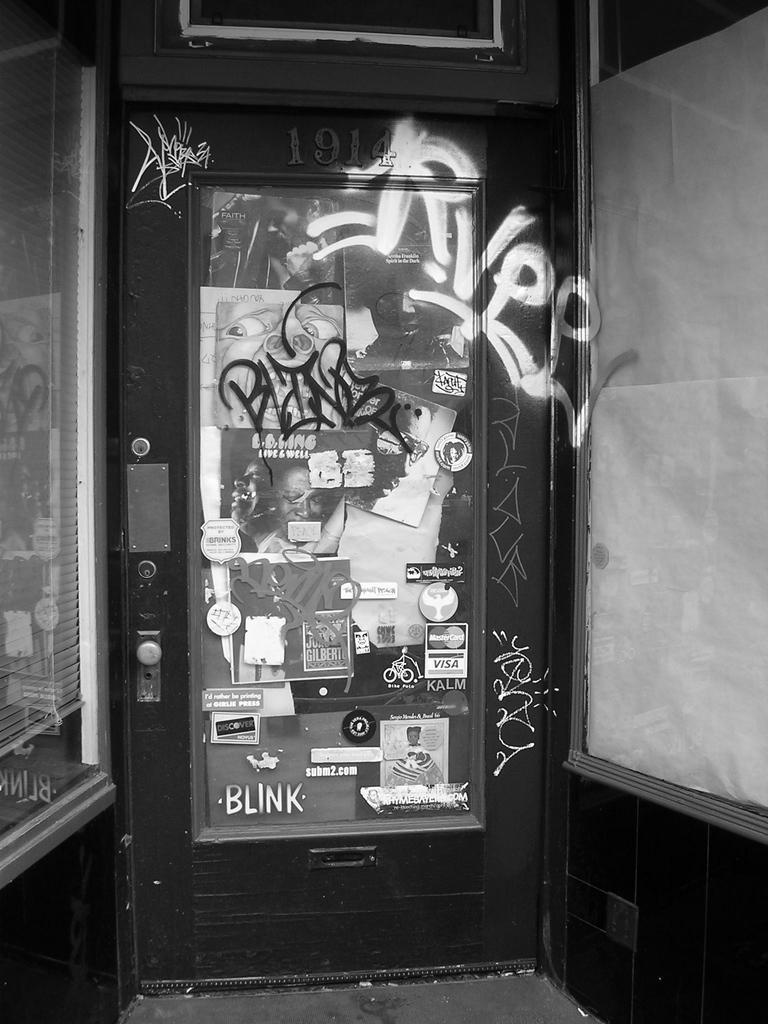Please provide a concise description of this image. In this image we can see a door, posters, glass walls, and a window blind. 